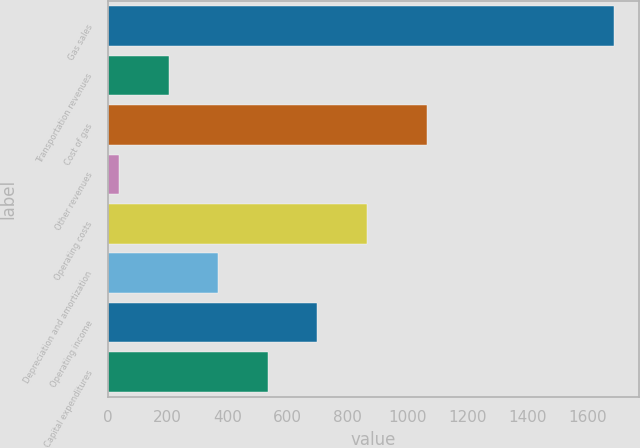Convert chart to OTSL. <chart><loc_0><loc_0><loc_500><loc_500><bar_chart><fcel>Gas sales<fcel>Transportation revenues<fcel>Cost of gas<fcel>Other revenues<fcel>Operating costs<fcel>Depreciation and amortization<fcel>Operating income<fcel>Capital expenditures<nl><fcel>1687.4<fcel>203.39<fcel>1062.5<fcel>38.5<fcel>862.95<fcel>368.28<fcel>698.06<fcel>533.17<nl></chart> 